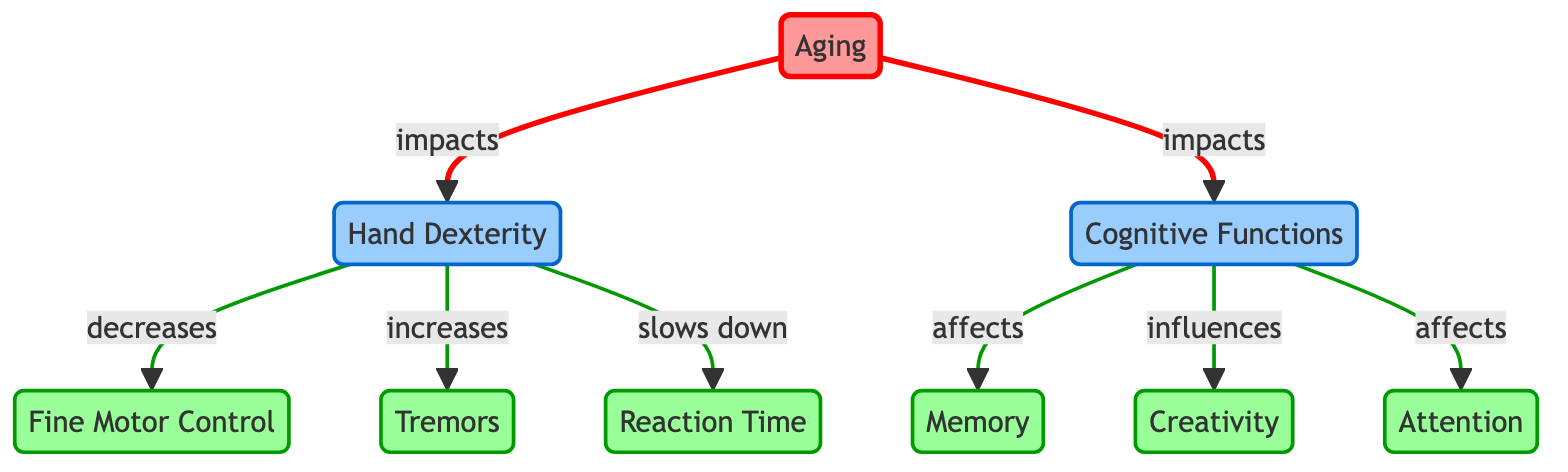What is the first node of the diagram? The first node, which represents the starting point of the flow diagram, is "Aging." This is identified as the source of several impacts on the other nodes.
Answer: Aging How many effects are linked to "Hand Dexterity"? "Hand Dexterity" is linked to three effects, which are "Fine Motor Control," "Tremors," and "Reaction Time." Each of these shows a different way that hand dexterity is affected.
Answer: 3 Which cognitive function is influenced by aging? "Cognitive Functions" is affected by aging, which is indicated by the direct impact arrow from "Aging" to "Cognitive Functions." This shows that as one ages, their cognitive functions are influenced.
Answer: Cognitive Functions What does aging do to hand dexterity? Aging impacts hand dexterity directly, and this relationship is shown through an impact arrow from "Aging" to "Hand Dexterity," indicating a negative influence.
Answer: Impacts Which two cognitive functions are affected by "Cognitive Functions"? "Creativity" and "Attention" are both influenced by "Cognitive Functions," as indicated by the arrows originating from "Cognitive Functions" leading to these nodes.
Answer: Creativity and Attention Overall, how many nodes are in the diagram? By counting all the unique entities within the diagram, including "Aging," "Hand Dexterity," "Cognitive Functions," and their respective effects, the total count comes to eight nodes.
Answer: 8 What effect results from decreased hand dexterity? A decrease in hand dexterity leads to a decrease in "Fine Motor Control," as evidenced by the directed link labeled "decreases" from "Hand Dexterity" to "Fine Motor Control."
Answer: Fine Motor Control What type of relationship exists between aging and cognitive functions? The relationship is one of impact, as shown by the directed arrow from "Aging" to "Cognitive Functions," indicating that aging negatively influences cognitive functions.
Answer: Impacts Which effect increases with decreased hand dexterity? "Tremors" increase as hand dexterity decreases, as indicated by the arrow labeled "increases" linking "Hand Dexterity" to "Tremors."
Answer: Tremors 